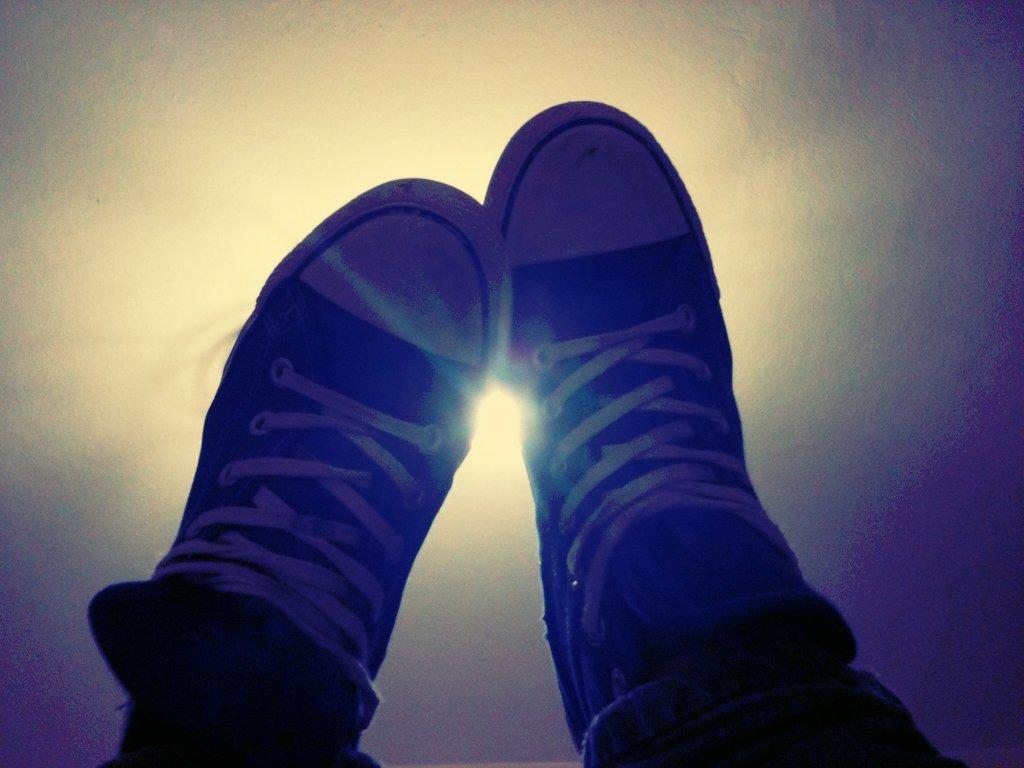What body part is visible in the image? There are human legs visible in the image. What are the human legs wearing? The human legs have shoes on them. Can you describe the lighting in the image? There is a light focus in the image. How many tickets can be seen in the image? There are no tickets present in the image. What type of mine is visible in the image? There is no mine present in the image. 